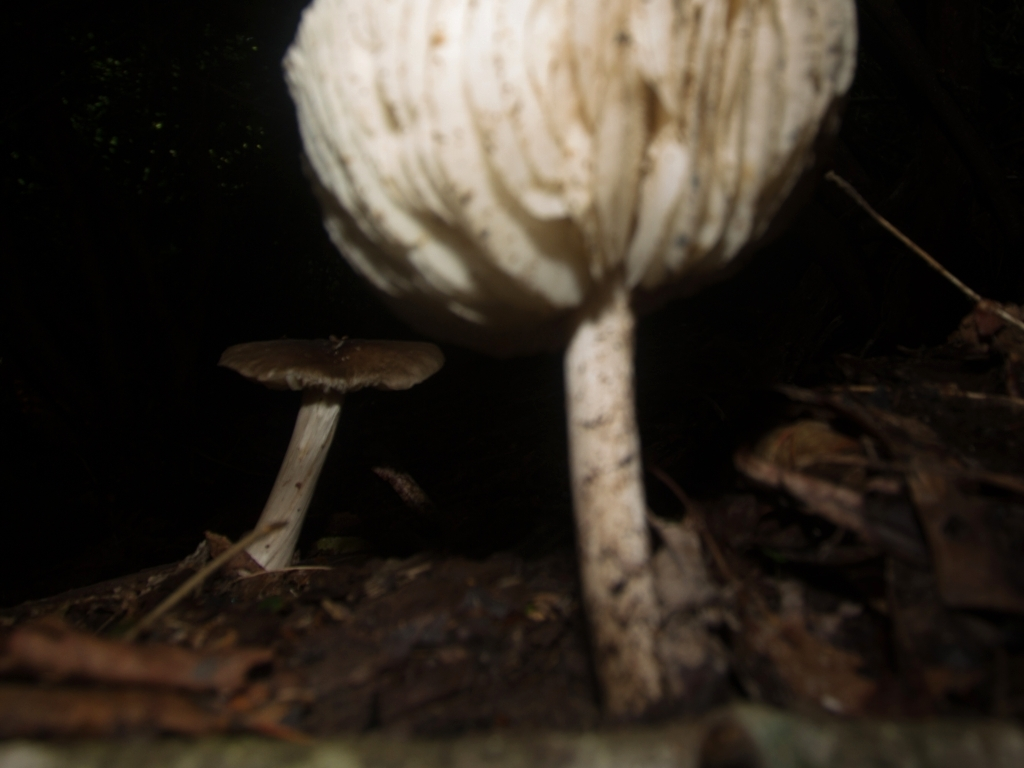Is there any significance to the way these mushrooms are positioned? The positioning of the mushrooms in the image seems to be natural and random, typical of how mushrooms might grow in the wild. They are not arranged in any discernible pattern, but their presence may indicate a healthy ecosystem where decomposing organic matter provides nutrients for various forms of life, including fungi. 